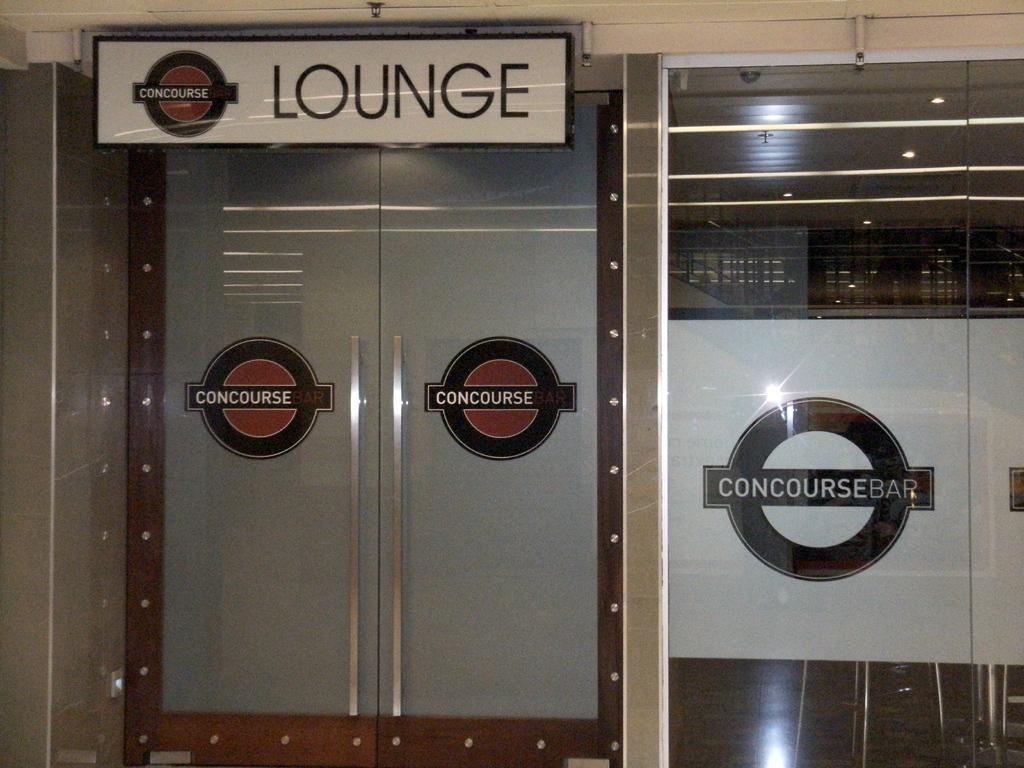What structure is located on the left side of the image? There is a door on the left side of the image. What type of wall is on the right side of the image? There is a glass wall on the right side of the image. What is on the left side of the image besides the door? There is a board on the left side of the image. What type of company is depicted on the board in the image? There is no company or any text on the board in the image; it is just a plain board. How many dolls can be seen playing in the mine in the image? There are no dolls or mines present in the image. 